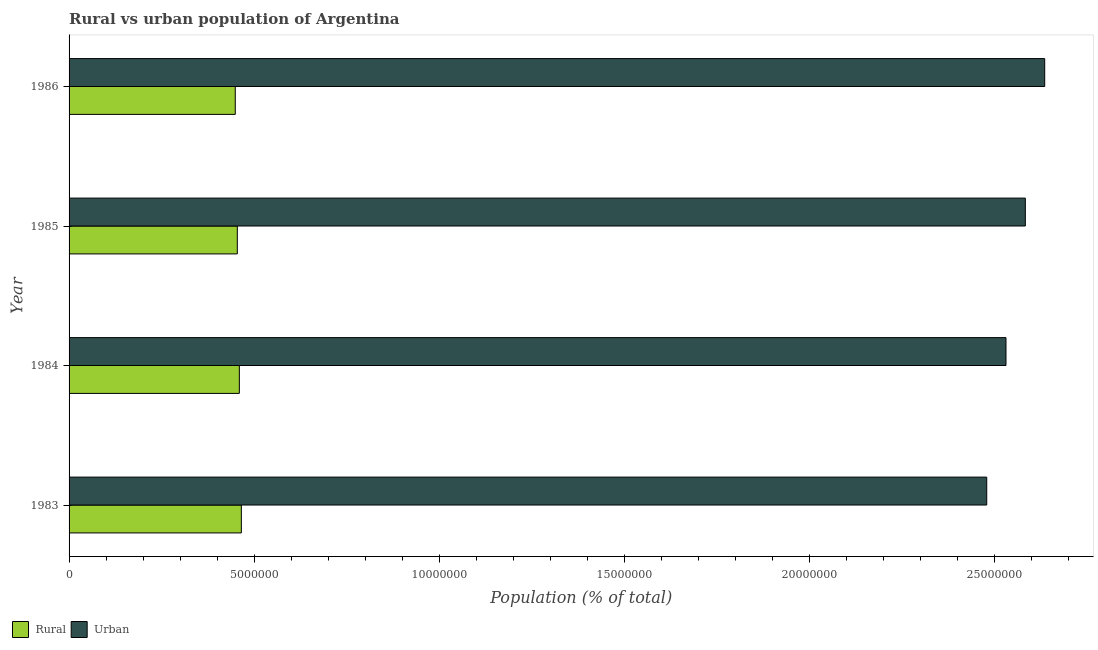How many different coloured bars are there?
Offer a terse response. 2. How many bars are there on the 1st tick from the top?
Provide a short and direct response. 2. How many bars are there on the 4th tick from the bottom?
Your answer should be compact. 2. What is the label of the 4th group of bars from the top?
Your answer should be compact. 1983. What is the urban population density in 1985?
Your response must be concise. 2.58e+07. Across all years, what is the maximum rural population density?
Keep it short and to the point. 4.66e+06. Across all years, what is the minimum rural population density?
Offer a terse response. 4.49e+06. In which year was the urban population density maximum?
Your answer should be compact. 1986. What is the total rural population density in the graph?
Provide a short and direct response. 1.83e+07. What is the difference between the urban population density in 1983 and that in 1984?
Provide a succinct answer. -5.20e+05. What is the difference between the rural population density in 1985 and the urban population density in 1984?
Give a very brief answer. -2.08e+07. What is the average rural population density per year?
Keep it short and to the point. 4.57e+06. In the year 1983, what is the difference between the urban population density and rural population density?
Give a very brief answer. 2.01e+07. What is the difference between the highest and the second highest rural population density?
Your answer should be compact. 5.41e+04. What is the difference between the highest and the lowest urban population density?
Your answer should be compact. 1.57e+06. In how many years, is the rural population density greater than the average rural population density taken over all years?
Provide a succinct answer. 2. What does the 1st bar from the top in 1983 represents?
Give a very brief answer. Urban. What does the 2nd bar from the bottom in 1986 represents?
Your answer should be very brief. Urban. How many years are there in the graph?
Your answer should be compact. 4. Does the graph contain any zero values?
Make the answer very short. No. Does the graph contain grids?
Your answer should be very brief. No. What is the title of the graph?
Your answer should be very brief. Rural vs urban population of Argentina. Does "Female" appear as one of the legend labels in the graph?
Make the answer very short. No. What is the label or title of the X-axis?
Offer a very short reply. Population (% of total). What is the label or title of the Y-axis?
Ensure brevity in your answer.  Year. What is the Population (% of total) in Rural in 1983?
Offer a terse response. 4.66e+06. What is the Population (% of total) in Urban in 1983?
Offer a very short reply. 2.48e+07. What is the Population (% of total) in Rural in 1984?
Provide a short and direct response. 4.60e+06. What is the Population (% of total) in Urban in 1984?
Offer a terse response. 2.53e+07. What is the Population (% of total) in Rural in 1985?
Make the answer very short. 4.55e+06. What is the Population (% of total) in Urban in 1985?
Your answer should be compact. 2.58e+07. What is the Population (% of total) of Rural in 1986?
Keep it short and to the point. 4.49e+06. What is the Population (% of total) of Urban in 1986?
Ensure brevity in your answer.  2.64e+07. Across all years, what is the maximum Population (% of total) in Rural?
Your answer should be very brief. 4.66e+06. Across all years, what is the maximum Population (% of total) in Urban?
Provide a short and direct response. 2.64e+07. Across all years, what is the minimum Population (% of total) of Rural?
Keep it short and to the point. 4.49e+06. Across all years, what is the minimum Population (% of total) of Urban?
Give a very brief answer. 2.48e+07. What is the total Population (% of total) in Rural in the graph?
Keep it short and to the point. 1.83e+07. What is the total Population (% of total) in Urban in the graph?
Your answer should be compact. 1.02e+08. What is the difference between the Population (% of total) in Rural in 1983 and that in 1984?
Offer a very short reply. 5.41e+04. What is the difference between the Population (% of total) of Urban in 1983 and that in 1984?
Provide a short and direct response. -5.20e+05. What is the difference between the Population (% of total) in Rural in 1983 and that in 1985?
Give a very brief answer. 1.09e+05. What is the difference between the Population (% of total) of Urban in 1983 and that in 1985?
Provide a succinct answer. -1.04e+06. What is the difference between the Population (% of total) of Rural in 1983 and that in 1986?
Your response must be concise. 1.64e+05. What is the difference between the Population (% of total) in Urban in 1983 and that in 1986?
Offer a terse response. -1.57e+06. What is the difference between the Population (% of total) of Rural in 1984 and that in 1985?
Give a very brief answer. 5.48e+04. What is the difference between the Population (% of total) of Urban in 1984 and that in 1985?
Provide a succinct answer. -5.23e+05. What is the difference between the Population (% of total) of Rural in 1984 and that in 1986?
Offer a very short reply. 1.10e+05. What is the difference between the Population (% of total) in Urban in 1984 and that in 1986?
Offer a very short reply. -1.05e+06. What is the difference between the Population (% of total) in Rural in 1985 and that in 1986?
Provide a short and direct response. 5.55e+04. What is the difference between the Population (% of total) in Urban in 1985 and that in 1986?
Offer a very short reply. -5.24e+05. What is the difference between the Population (% of total) in Rural in 1983 and the Population (% of total) in Urban in 1984?
Ensure brevity in your answer.  -2.07e+07. What is the difference between the Population (% of total) in Rural in 1983 and the Population (% of total) in Urban in 1985?
Your answer should be very brief. -2.12e+07. What is the difference between the Population (% of total) of Rural in 1983 and the Population (% of total) of Urban in 1986?
Keep it short and to the point. -2.17e+07. What is the difference between the Population (% of total) of Rural in 1984 and the Population (% of total) of Urban in 1985?
Ensure brevity in your answer.  -2.12e+07. What is the difference between the Population (% of total) in Rural in 1984 and the Population (% of total) in Urban in 1986?
Keep it short and to the point. -2.18e+07. What is the difference between the Population (% of total) of Rural in 1985 and the Population (% of total) of Urban in 1986?
Offer a very short reply. -2.18e+07. What is the average Population (% of total) in Rural per year?
Keep it short and to the point. 4.57e+06. What is the average Population (% of total) of Urban per year?
Provide a succinct answer. 2.56e+07. In the year 1983, what is the difference between the Population (% of total) of Rural and Population (% of total) of Urban?
Your answer should be very brief. -2.01e+07. In the year 1984, what is the difference between the Population (% of total) of Rural and Population (% of total) of Urban?
Give a very brief answer. -2.07e+07. In the year 1985, what is the difference between the Population (% of total) in Rural and Population (% of total) in Urban?
Your answer should be compact. -2.13e+07. In the year 1986, what is the difference between the Population (% of total) in Rural and Population (% of total) in Urban?
Make the answer very short. -2.19e+07. What is the ratio of the Population (% of total) of Rural in 1983 to that in 1984?
Keep it short and to the point. 1.01. What is the ratio of the Population (% of total) in Urban in 1983 to that in 1984?
Your answer should be very brief. 0.98. What is the ratio of the Population (% of total) in Rural in 1983 to that in 1985?
Give a very brief answer. 1.02. What is the ratio of the Population (% of total) in Urban in 1983 to that in 1985?
Keep it short and to the point. 0.96. What is the ratio of the Population (% of total) of Rural in 1983 to that in 1986?
Your answer should be compact. 1.04. What is the ratio of the Population (% of total) in Urban in 1983 to that in 1986?
Offer a very short reply. 0.94. What is the ratio of the Population (% of total) in Rural in 1984 to that in 1985?
Provide a short and direct response. 1.01. What is the ratio of the Population (% of total) of Urban in 1984 to that in 1985?
Provide a succinct answer. 0.98. What is the ratio of the Population (% of total) of Rural in 1984 to that in 1986?
Make the answer very short. 1.02. What is the ratio of the Population (% of total) in Urban in 1984 to that in 1986?
Provide a succinct answer. 0.96. What is the ratio of the Population (% of total) of Rural in 1985 to that in 1986?
Your response must be concise. 1.01. What is the ratio of the Population (% of total) in Urban in 1985 to that in 1986?
Your answer should be very brief. 0.98. What is the difference between the highest and the second highest Population (% of total) of Rural?
Provide a short and direct response. 5.41e+04. What is the difference between the highest and the second highest Population (% of total) of Urban?
Your answer should be very brief. 5.24e+05. What is the difference between the highest and the lowest Population (% of total) in Rural?
Make the answer very short. 1.64e+05. What is the difference between the highest and the lowest Population (% of total) in Urban?
Keep it short and to the point. 1.57e+06. 